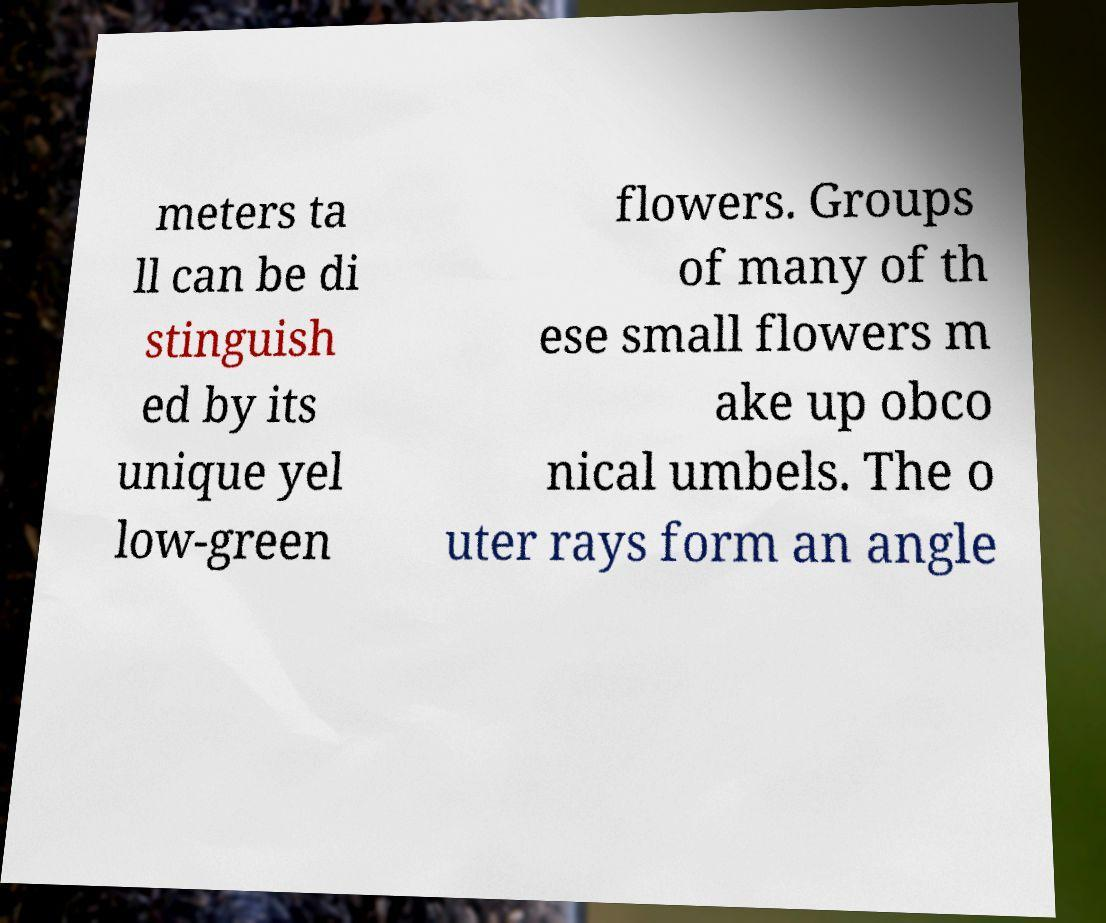For documentation purposes, I need the text within this image transcribed. Could you provide that? meters ta ll can be di stinguish ed by its unique yel low-green flowers. Groups of many of th ese small flowers m ake up obco nical umbels. The o uter rays form an angle 